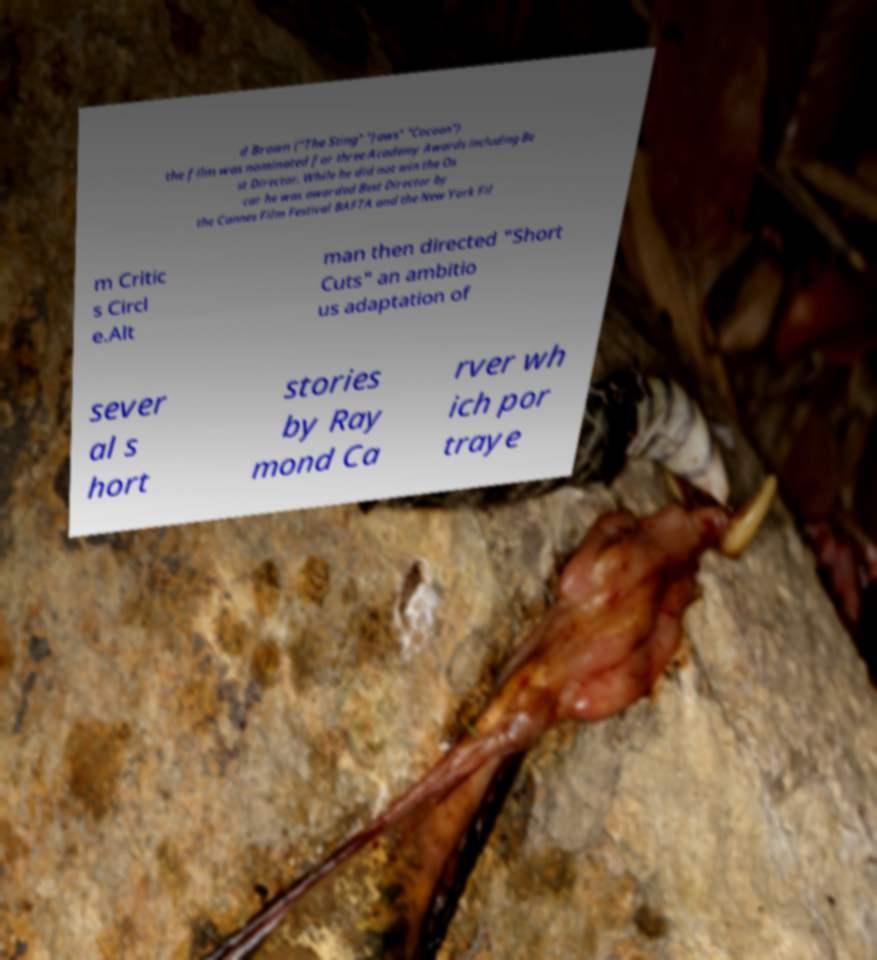Can you read and provide the text displayed in the image?This photo seems to have some interesting text. Can you extract and type it out for me? d Brown ("The Sting" "Jaws" "Cocoon") the film was nominated for three Academy Awards including Be st Director. While he did not win the Os car he was awarded Best Director by the Cannes Film Festival BAFTA and the New York Fil m Critic s Circl e.Alt man then directed "Short Cuts" an ambitio us adaptation of sever al s hort stories by Ray mond Ca rver wh ich por traye 